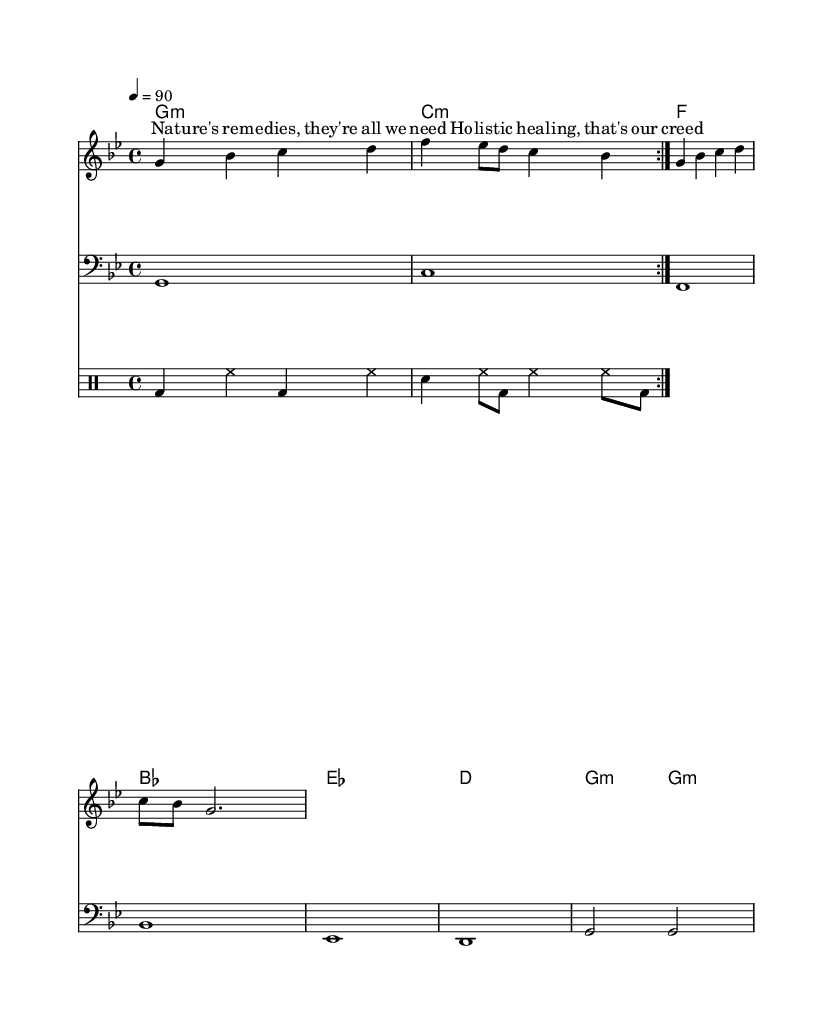What is the key signature of this music? The key signature is G minor, which has two flats indicated by the 'b' symbols next to the staff at the beginning of the piece.
Answer: G minor What is the time signature of this music? The time signature is 4/4, which means there are four beats in each measure, represented at the beginning of the sheet music.
Answer: 4/4 What is the tempo marking of the piece? The tempo marking is quarter note equals 90, which indicates the speed at which the piece should be played. This is noted at the beginning of the score.
Answer: 90 How many measures does the melody section contain? The melody section contains four measures which can be counted individually from the staff where the melody is written.
Answer: 4 What is the genre of this piece? The genre is Hip Hop, as indicated by the style of the lyrics and the general structure of the music, including rhythm and flow.
Answer: Hip Hop What harmonic progression is used in the music? The harmonic progression combines G minor, C minor, F, and B flat, which consists of both minor and major chords indicated in the chord section of the score.
Answer: G minor, C minor, F, B flat Which holistic theme is highlighted in the lyrics? The theme highlighted in the lyrics focuses on natural remedies and holistic healing, as directly stated in the lyrics section of the sheet music.
Answer: Natural remedies and holistic healing 